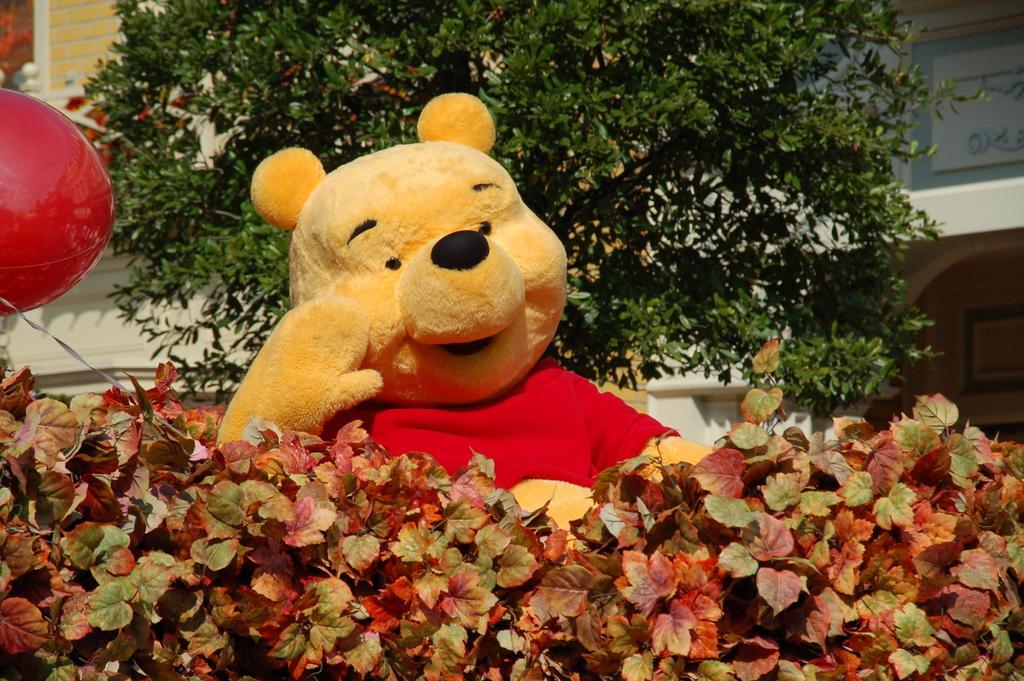Describe this image in one or two sentences. There are plants and a toy in the foreground area of the image, it seems like a house and a tree in the background. 